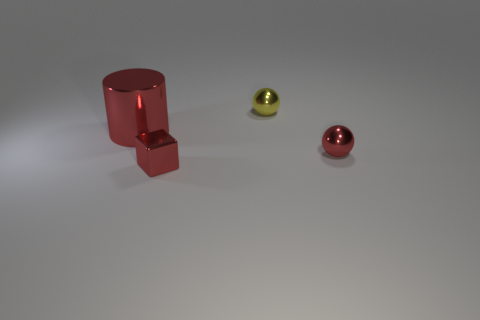Does the block have the same size as the metallic cylinder?
Ensure brevity in your answer.  No. How many other objects are the same shape as the tiny yellow object?
Give a very brief answer. 1. What is the shape of the tiny yellow metal object right of the large metal cylinder?
Your answer should be very brief. Sphere. There is a small object that is behind the metal cylinder; does it have the same shape as the red thing that is right of the yellow metal object?
Make the answer very short. Yes. Are there an equal number of cylinders that are on the right side of the small red sphere and tiny yellow shiny spheres?
Your answer should be compact. No. Is there anything else that has the same size as the metallic cylinder?
Give a very brief answer. No. What is the material of the red object that is the same shape as the tiny yellow metallic object?
Your response must be concise. Metal. There is a metal thing that is in front of the shiny ball that is in front of the big metallic object; what is its shape?
Keep it short and to the point. Cube. Is the small ball behind the big red metal cylinder made of the same material as the large red cylinder?
Ensure brevity in your answer.  Yes. Is the number of metal spheres that are behind the yellow sphere the same as the number of red metal balls that are right of the red ball?
Provide a succinct answer. Yes. 